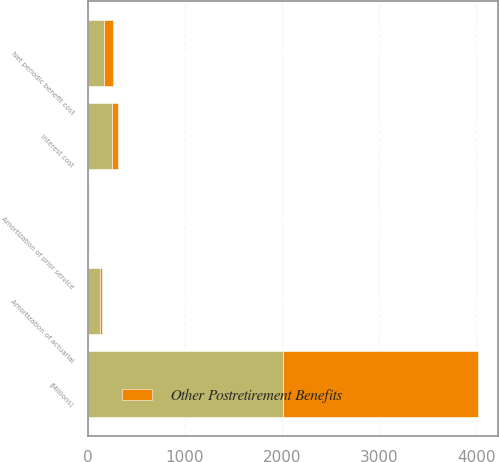Convert chart to OTSL. <chart><loc_0><loc_0><loc_500><loc_500><stacked_bar_chart><ecel><fcel>(Millions)<fcel>Interest cost<fcel>Amortization of prior service<fcel>Amortization of actuarial<fcel>Net periodic benefit cost<nl><fcel>nan<fcel>2010<fcel>249<fcel>5<fcel>121<fcel>161<nl><fcel>Other Postretirement Benefits<fcel>2010<fcel>64<fcel>5<fcel>19<fcel>97<nl></chart> 